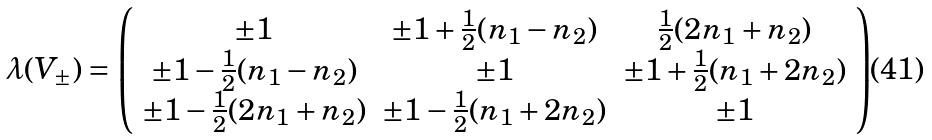<formula> <loc_0><loc_0><loc_500><loc_500>\lambda ( V _ { \pm } ) = \left ( \begin{array} { c c c } \pm 1 & \pm 1 + \frac { 1 } { 2 } ( n _ { 1 } - n _ { 2 } ) & \frac { 1 } { 2 } ( 2 n _ { 1 } + n _ { 2 } ) \\ \pm 1 - \frac { 1 } { 2 } ( n _ { 1 } - n _ { 2 } ) & \pm 1 & \pm 1 + \frac { 1 } { 2 } ( n _ { 1 } + 2 n _ { 2 } ) \\ \pm 1 - \frac { 1 } { 2 } ( 2 n _ { 1 } + n _ { 2 } ) & \pm 1 - \frac { 1 } { 2 } ( n _ { 1 } + 2 n _ { 2 } ) & \pm 1 \end{array} \right )</formula> 